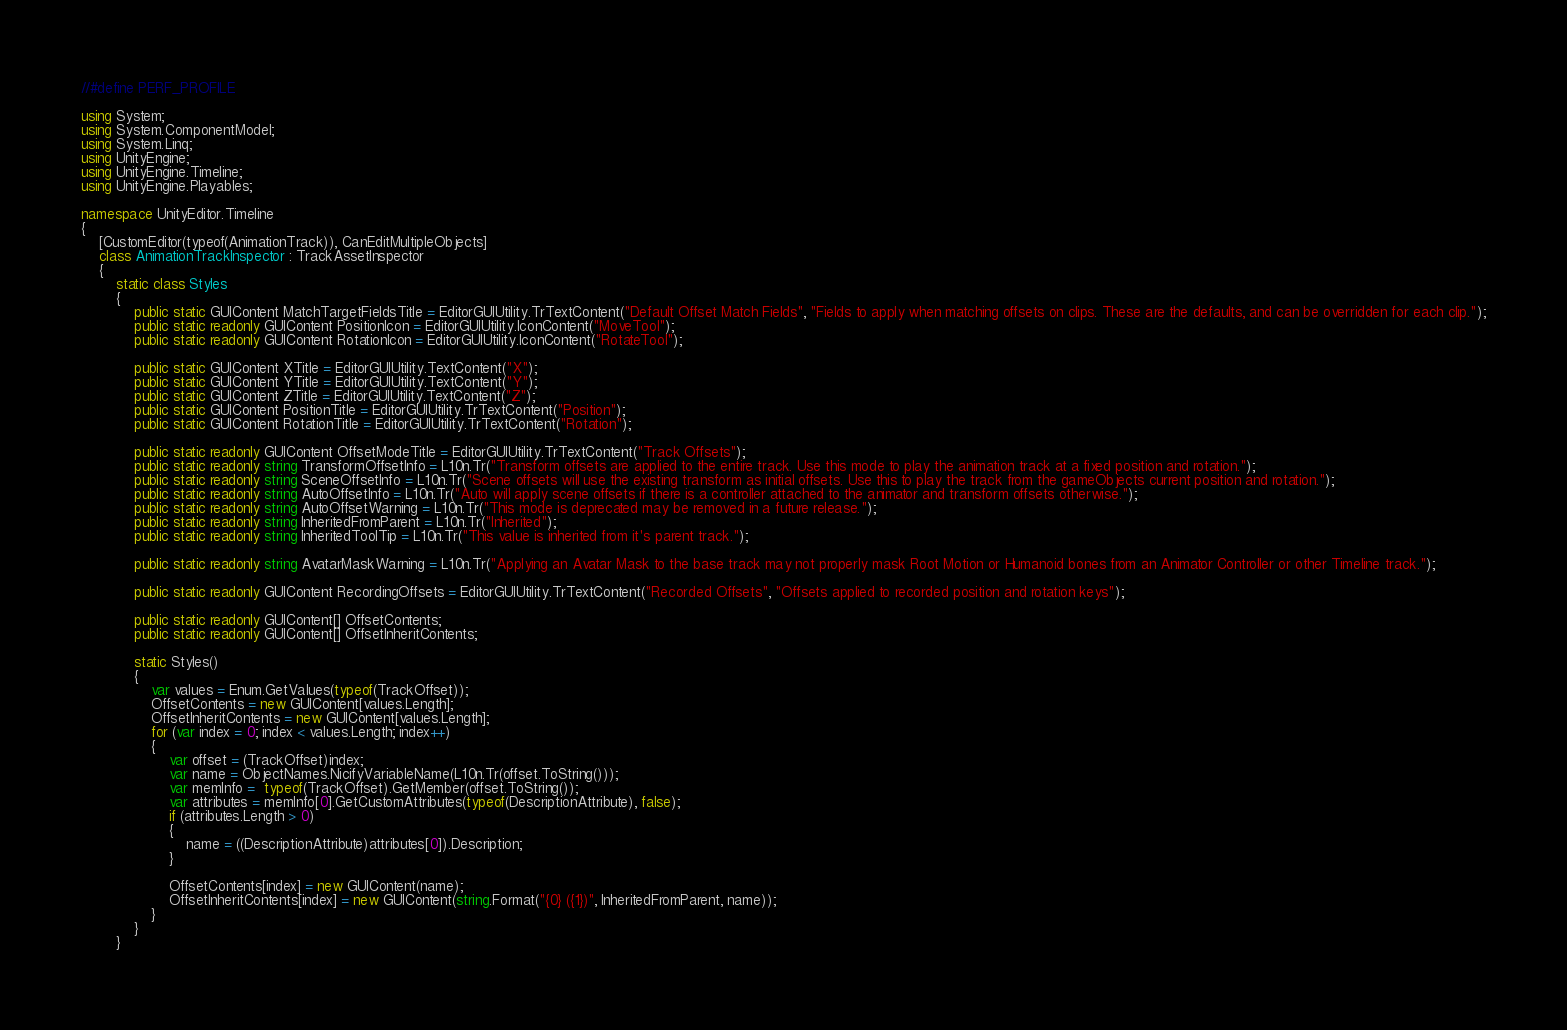Convert code to text. <code><loc_0><loc_0><loc_500><loc_500><_C#_>//#define PERF_PROFILE

using System;
using System.ComponentModel;
using System.Linq;
using UnityEngine;
using UnityEngine.Timeline;
using UnityEngine.Playables;

namespace UnityEditor.Timeline
{
    [CustomEditor(typeof(AnimationTrack)), CanEditMultipleObjects]
    class AnimationTrackInspector : TrackAssetInspector
    {
        static class Styles
        {
            public static GUIContent MatchTargetFieldsTitle = EditorGUIUtility.TrTextContent("Default Offset Match Fields", "Fields to apply when matching offsets on clips. These are the defaults, and can be overridden for each clip.");
            public static readonly GUIContent PositionIcon = EditorGUIUtility.IconContent("MoveTool");
            public static readonly GUIContent RotationIcon = EditorGUIUtility.IconContent("RotateTool");

            public static GUIContent XTitle = EditorGUIUtility.TextContent("X");
            public static GUIContent YTitle = EditorGUIUtility.TextContent("Y");
            public static GUIContent ZTitle = EditorGUIUtility.TextContent("Z");
            public static GUIContent PositionTitle = EditorGUIUtility.TrTextContent("Position");
            public static GUIContent RotationTitle = EditorGUIUtility.TrTextContent("Rotation");

            public static readonly GUIContent OffsetModeTitle = EditorGUIUtility.TrTextContent("Track Offsets");
            public static readonly string TransformOffsetInfo = L10n.Tr("Transform offsets are applied to the entire track. Use this mode to play the animation track at a fixed position and rotation.");
            public static readonly string SceneOffsetInfo = L10n.Tr("Scene offsets will use the existing transform as initial offsets. Use this to play the track from the gameObjects current position and rotation.");
            public static readonly string AutoOffsetInfo = L10n.Tr("Auto will apply scene offsets if there is a controller attached to the animator and transform offsets otherwise.");
            public static readonly string AutoOffsetWarning = L10n.Tr("This mode is deprecated may be removed in a future release.");
            public static readonly string InheritedFromParent = L10n.Tr("Inherited");
            public static readonly string InheritedToolTip = L10n.Tr("This value is inherited from it's parent track.");

            public static readonly string AvatarMaskWarning = L10n.Tr("Applying an Avatar Mask to the base track may not properly mask Root Motion or Humanoid bones from an Animator Controller or other Timeline track.");

            public static readonly GUIContent RecordingOffsets = EditorGUIUtility.TrTextContent("Recorded Offsets", "Offsets applied to recorded position and rotation keys");

            public static readonly GUIContent[] OffsetContents;
            public static readonly GUIContent[] OffsetInheritContents;

            static Styles()
            {
                var values = Enum.GetValues(typeof(TrackOffset));
                OffsetContents = new GUIContent[values.Length];
                OffsetInheritContents = new GUIContent[values.Length];
                for (var index = 0; index < values.Length; index++)
                {
                    var offset = (TrackOffset)index;
                    var name = ObjectNames.NicifyVariableName(L10n.Tr(offset.ToString()));
                    var memInfo =  typeof(TrackOffset).GetMember(offset.ToString());
                    var attributes = memInfo[0].GetCustomAttributes(typeof(DescriptionAttribute), false);
                    if (attributes.Length > 0)
                    {
                        name = ((DescriptionAttribute)attributes[0]).Description;
                    }

                    OffsetContents[index] = new GUIContent(name);
                    OffsetInheritContents[index] = new GUIContent(string.Format("{0} ({1})", InheritedFromParent, name));
                }
            }
        }
</code> 